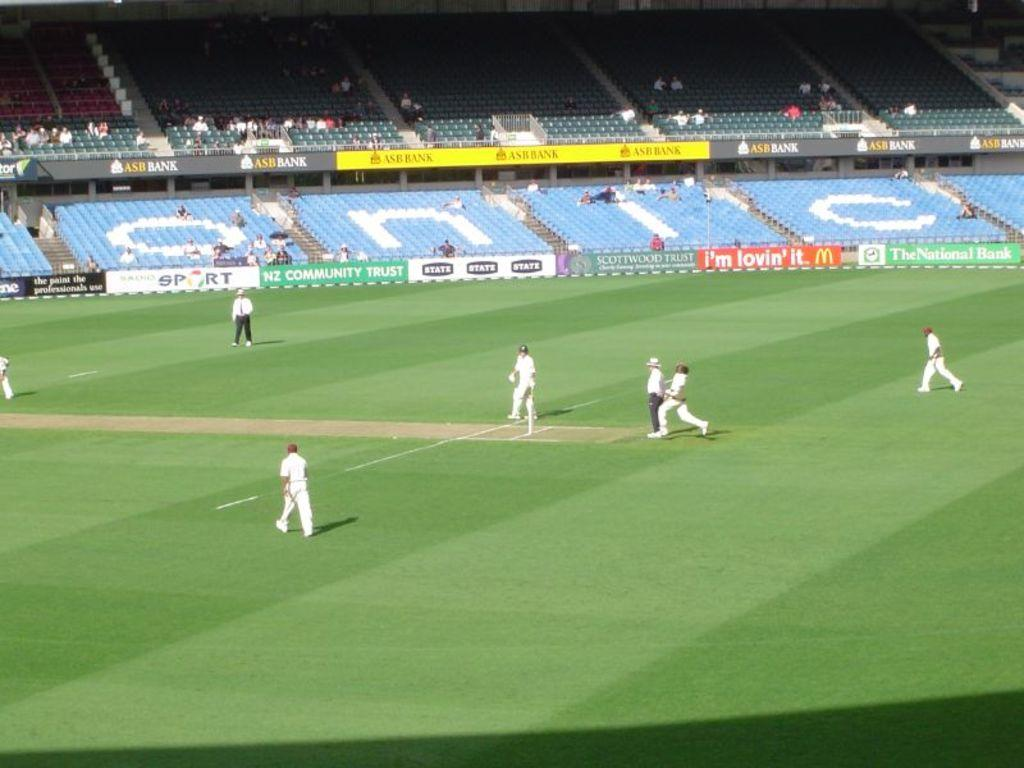<image>
Present a compact description of the photo's key features. a group of players playing soccer next to bleachers that read onic 